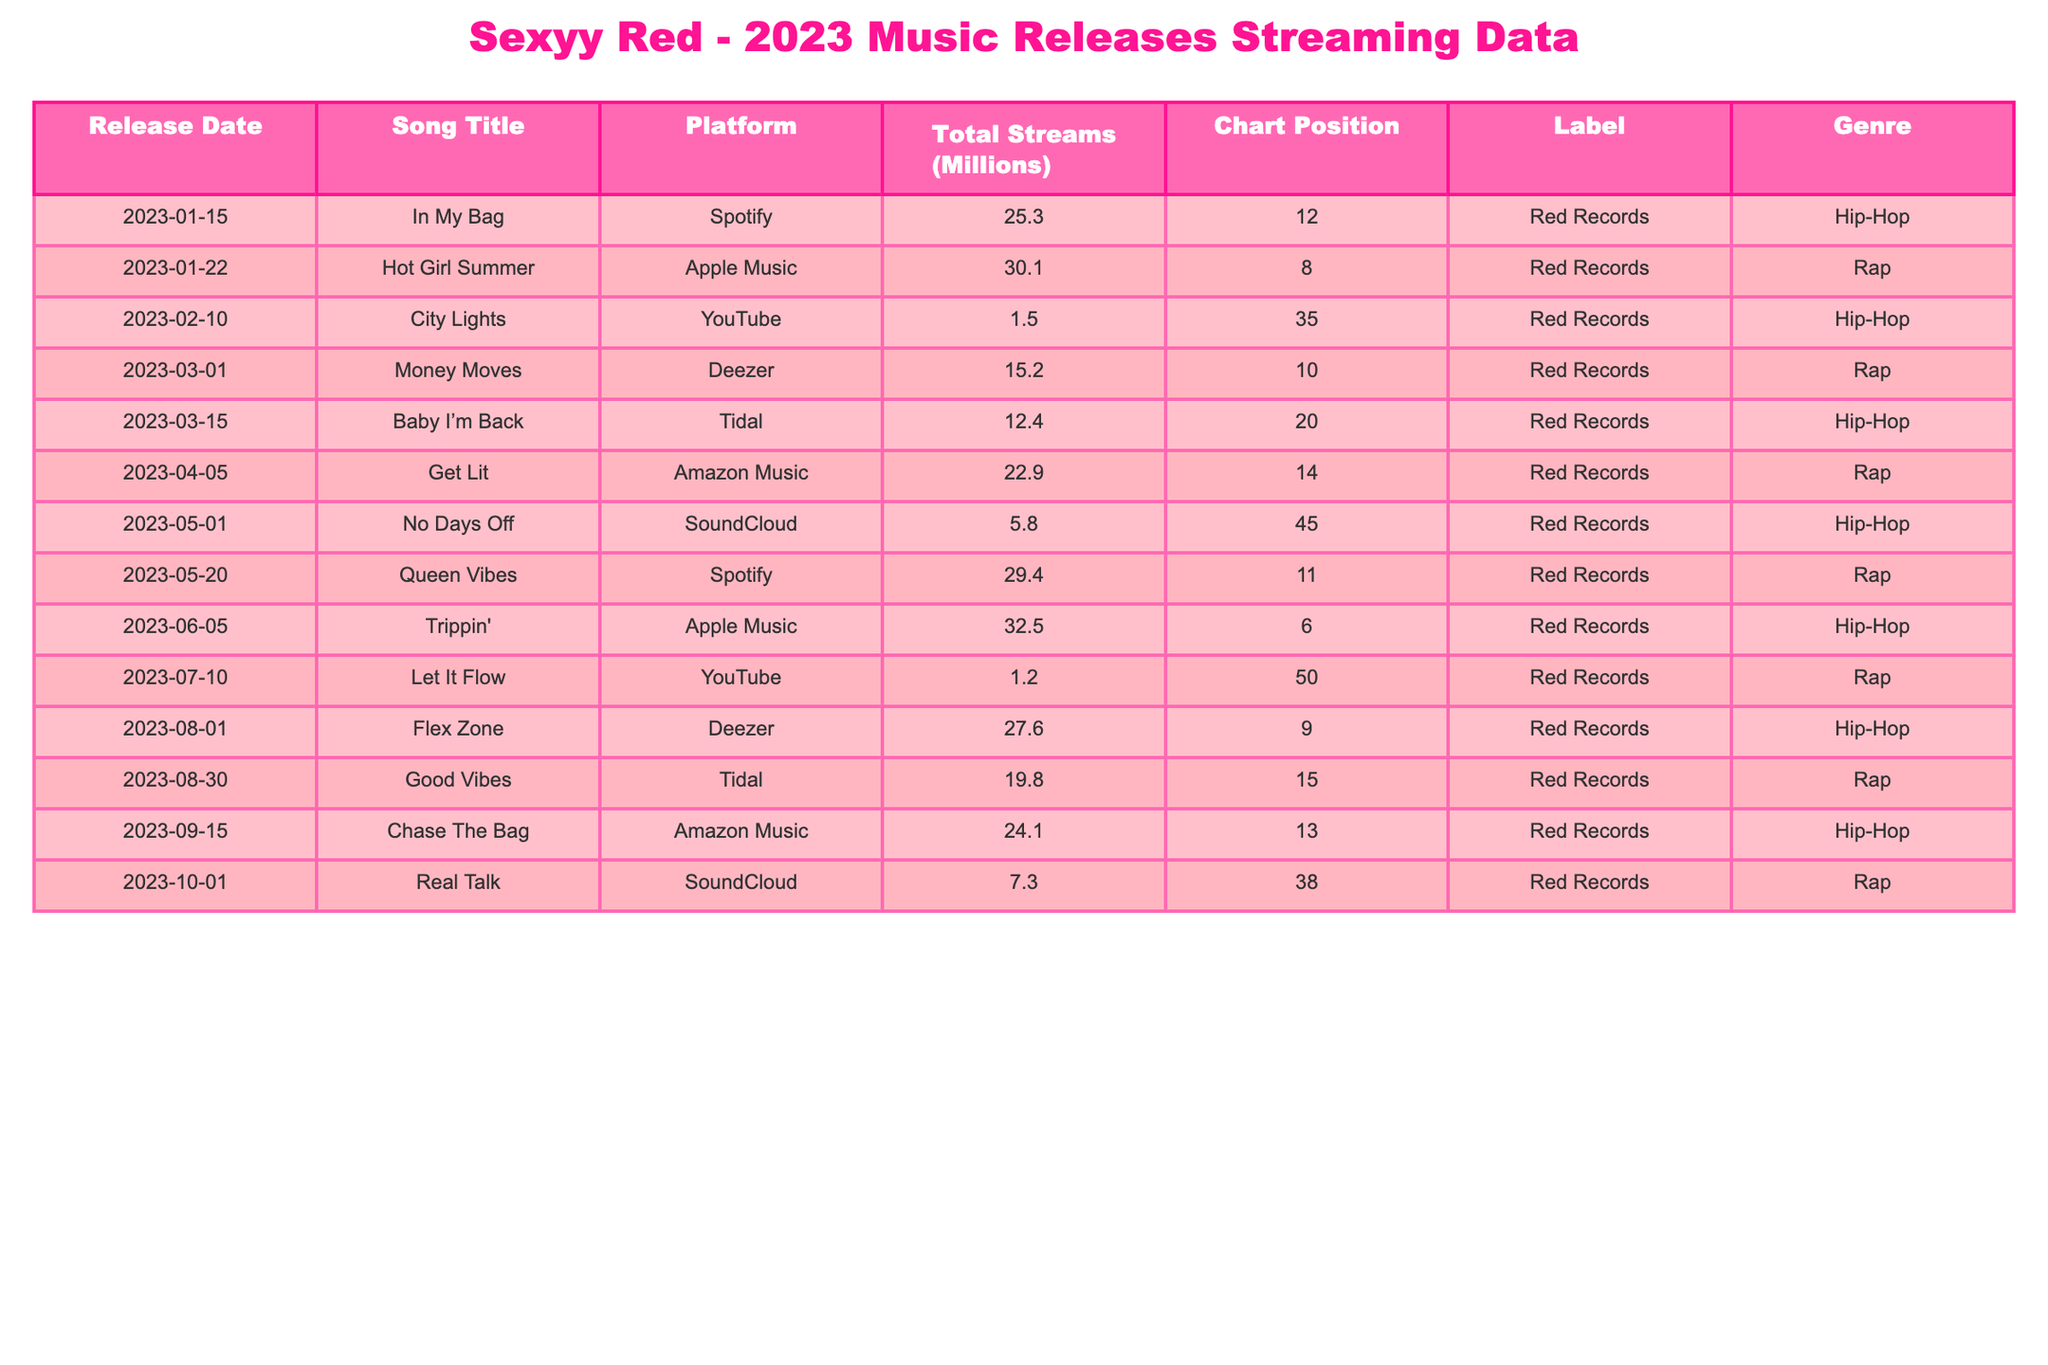What is the total number of streams for all songs released in 2023? To find the total number of streams, we sum the "Total Streams (Millions)" column: 25.3 + 30.1 + 1.5 + 15.2 + 12.4 + 22.9 + 5.8 + 29.4 + 32.5 + 1.2 + 27.6 + 19.8 + 24.1 + 7.3 =  322.8 million
Answer: 322.8 million Which song has the highest number of total streams? By reviewing the "Total Streams (Millions)" column, "Trippin'" with 32.5 million streams has the highest count
Answer: Trippin' What was the chart position of “Hot Girl Summer”? By locating "Hot Girl Summer" in the table, we see its corresponding "Chart Position" is 8
Answer: 8 How many songs are listed as being on the platform SoundCloud? The table shows two songs under "SoundCloud”: "No Days Off" and "Real Talk," which makes it a total of 2 songs
Answer: 2 Which platform had the least number of streams for Sexyy Red's music? Looking at the "Total Streams (Millions)" column, "City Lights" on YouTube has 1.5 million streams, the lowest among all songs in the table
Answer: YouTube What is the average number of streams for the Rap genre? There are 7 songs categorized as Rap with the following streams: 30.1, 12.4, 22.9, 29.4, 32.5, 19.8, and 24.1. Summing these gives us  30.1 + 12.4 + 22.9 + 29.4 + 32.5 + 19.8 + 24.1 = 171.2 million. Dividing by 7 gives an average of 171.2 / 7 = 24.4 million
Answer: 24.4 million Was there any song released on Apple Music that achieved a chart position of 6 or lower? Review the "Chart Position" for songs released on Apple Music. "Hot Girl Summer" (position 8) and "Trippin'" (position 6) indicates that yes, there is one song ("Trippin'") with a chart position of 6 or lower
Answer: Yes What is the difference in total streams between the song with the highest total streams and the one with the lowest? "Trippin'" has the highest streams at 32.5 million, and "City Lights" has the lowest at 1.5 million. The difference is 32.5 - 1.5 = 31 million
Answer: 31 million How many songs released in 2023 had more than 20 million total streams? The songs with over 20 million streams are: "Hot Girl Summer" (30.1), "Trippin'" (32.5), "Queen Vibes" (29.4), "Flex Zone" (27.6), "Chase The Bag" (24.1). Counting these, we find there are 5 songs with over 20 million streams
Answer: 5 Which genre had the most songs released in 2023? By counting the number of entries under each genre, "Rap" has 7 entries and "Hip-Hop" has 7 entries. Therefore, both genres have an equal number of songs
Answer: Both genres are equal 